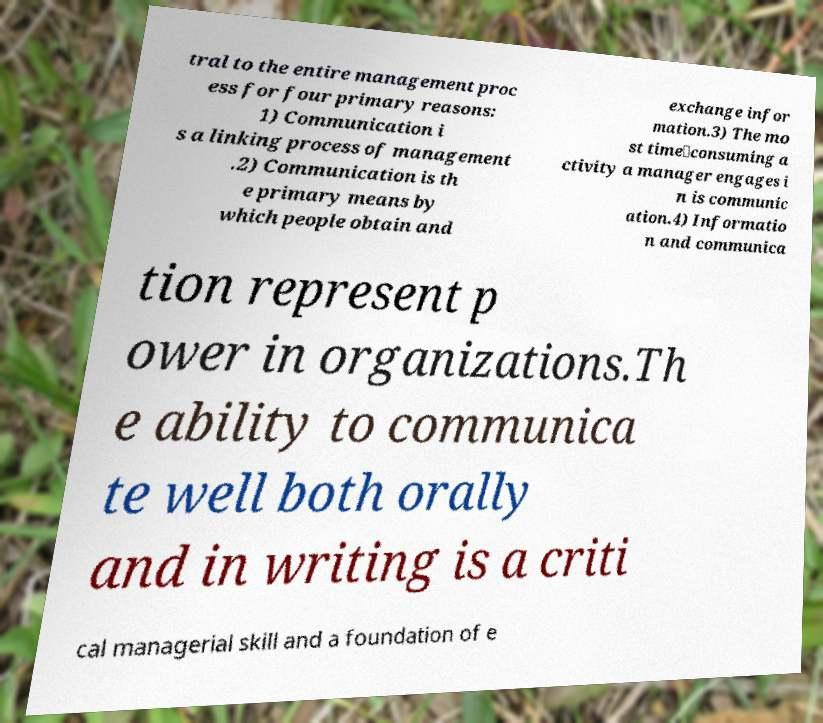Can you accurately transcribe the text from the provided image for me? tral to the entire management proc ess for four primary reasons: 1) Communication i s a linking process of management .2) Communication is th e primary means by which people obtain and exchange infor mation.3) The mo st time‐consuming a ctivity a manager engages i n is communic ation.4) Informatio n and communica tion represent p ower in organizations.Th e ability to communica te well both orally and in writing is a criti cal managerial skill and a foundation of e 